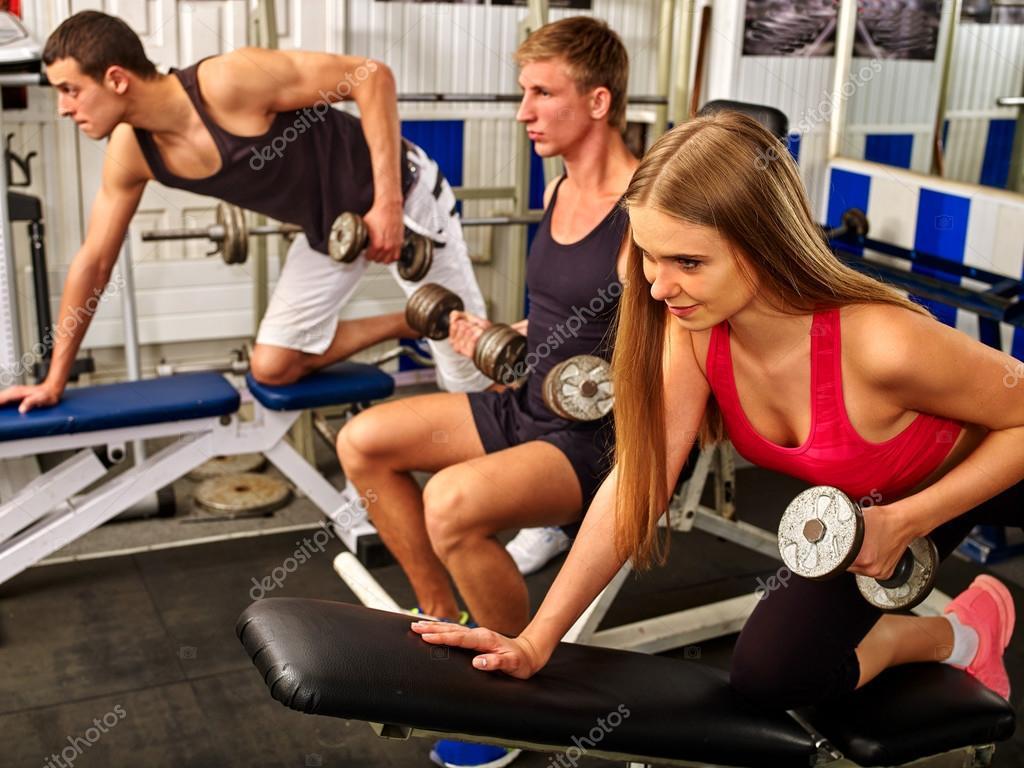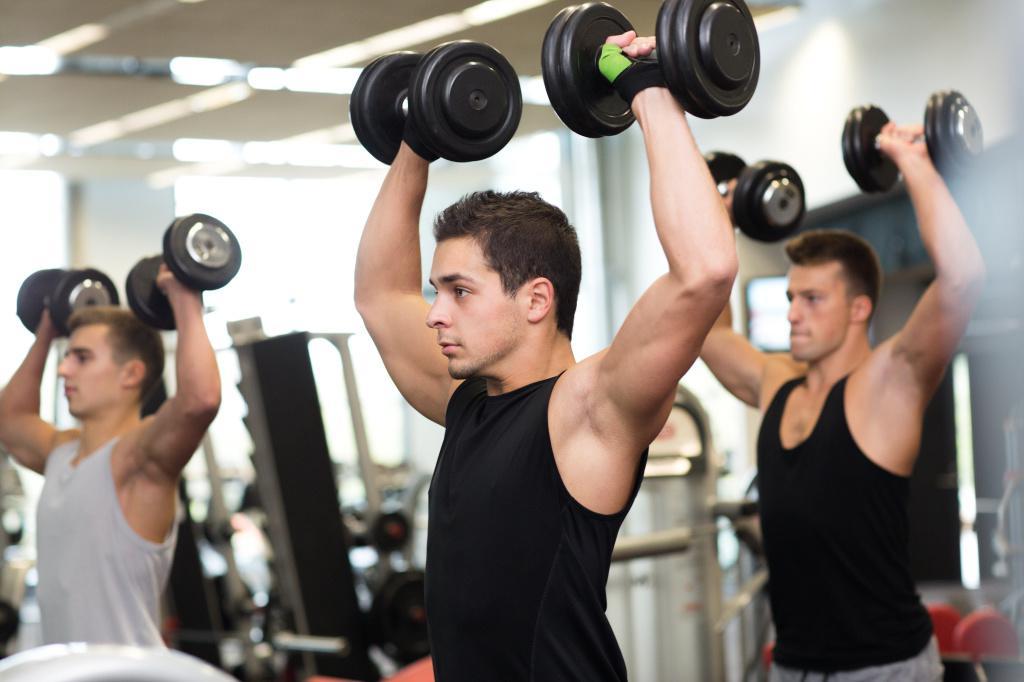The first image is the image on the left, the second image is the image on the right. Examine the images to the left and right. Is the description "A person is holding a weight above their head." accurate? Answer yes or no. Yes. The first image is the image on the left, the second image is the image on the right. Examine the images to the left and right. Is the description "The left and right image contains the same number of people working out." accurate? Answer yes or no. Yes. 